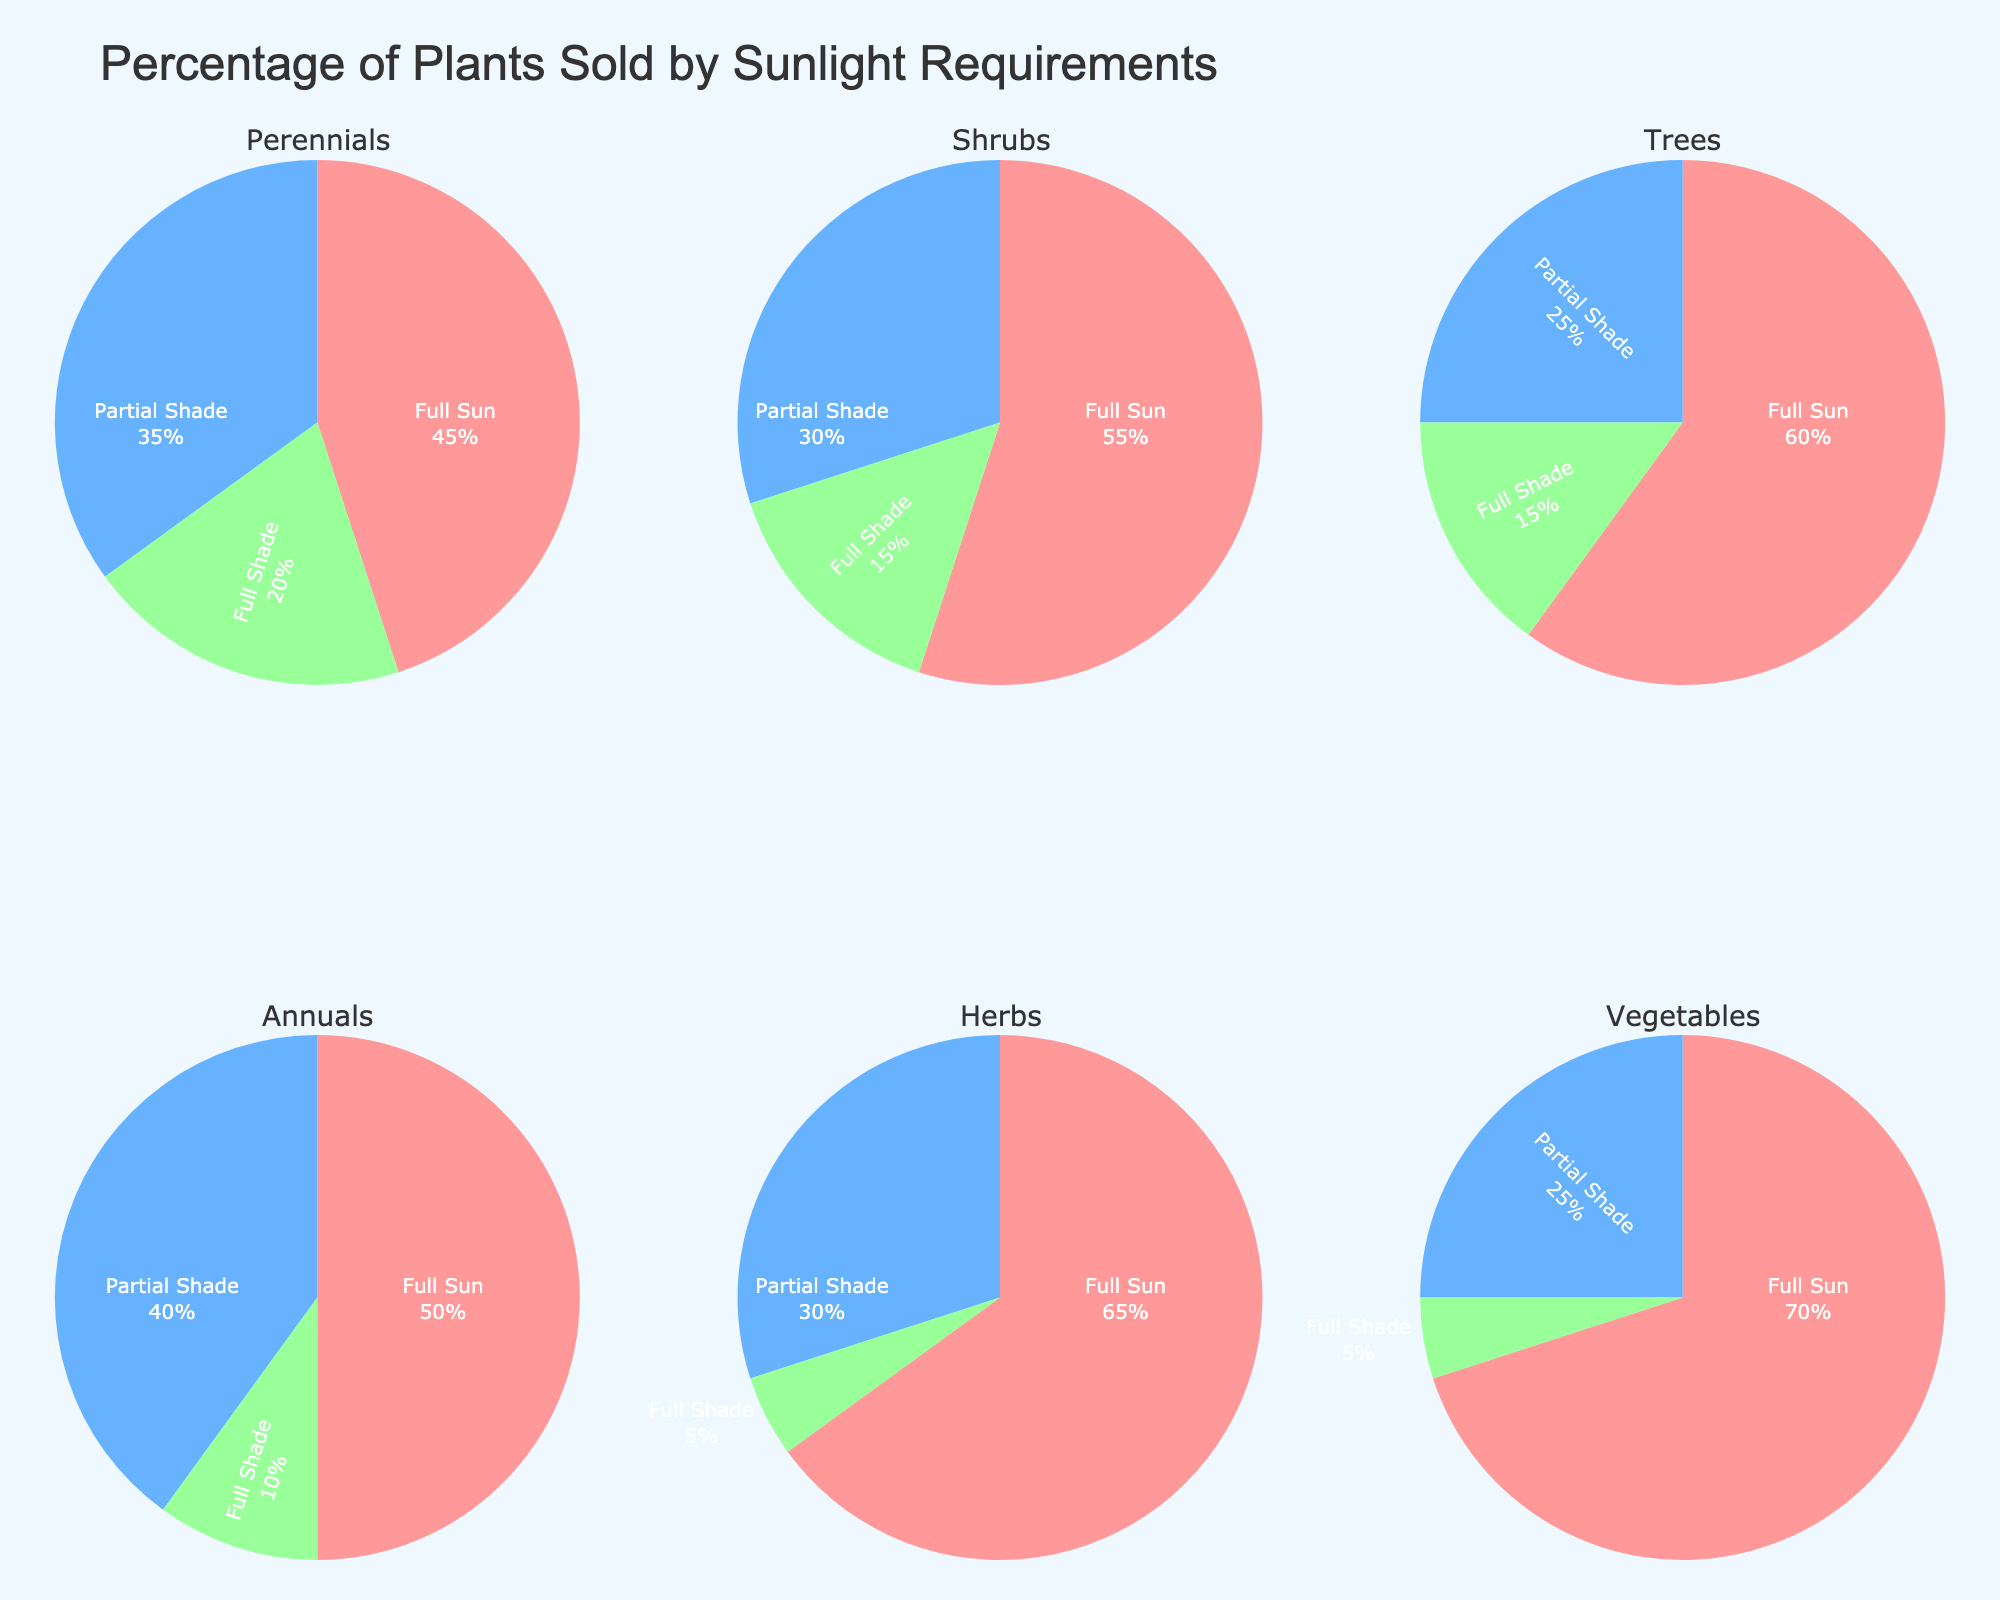What is the percentage of the Agriculture sector in Mosul's pre-conflict economy? The Agriculture sector's percentage is directly shown on the pie chart on the left.
Answer: 15% Which sector has the highest percentage in Mosul's pre-conflict economy? By observing the pie charts, the sector with the largest area is identified, which is the Oil and Gas sector.
Answer: Oil and Gas How many sectors are represented in the main economic breakdown pie chart? Count the distinct sectors displayed in the left pie chart.
Answer: Seven sectors What's the combined percentage of the top three sectors in Mosul's pre-conflict economy? From the chart on the right, the top three sectors are Oil and Gas (22%), Retail and Trade (20%), and Manufacturing (18%). Sum these percentages.
Answer: 60% Which sector has the smallest percentage and what is it? The smallest sector by visual inspection is the Healthcare sector, labeled with the percentage.
Answer: Healthcare, 6% Compare the combined percentage of Agriculture and Construction sectors to Retail and Trade. Which is higher? Sum the percentages of Agriculture (15%) and Construction (12%), then compare to the percentage of Retail and Trade (20%).
Answer: Agriculture and Construction (27%) is higher than Retail and Trade (20%) How much larger is the Oil and Gas sector compared to the Healthcare sector? Subtract the percentage of the Healthcare sector (6%) from that of the Oil and Gas sector (22%).
Answer: 16% What is the title of the figure? The title is found at the top of the plot.
Answer: Mosul's Pre-Conflict Economy Which three sectors are highlighted in the top three sectors pie chart? The sectors are directly shown in the right pie chart.
Answer: Oil and Gas, Retail and Trade, Manufacturing What combined percentage of the economy do the sectors outside the top three sectors contribute? Subtract the top three sectors' combined percentage (60%) from 100%.
Answer: 40% 